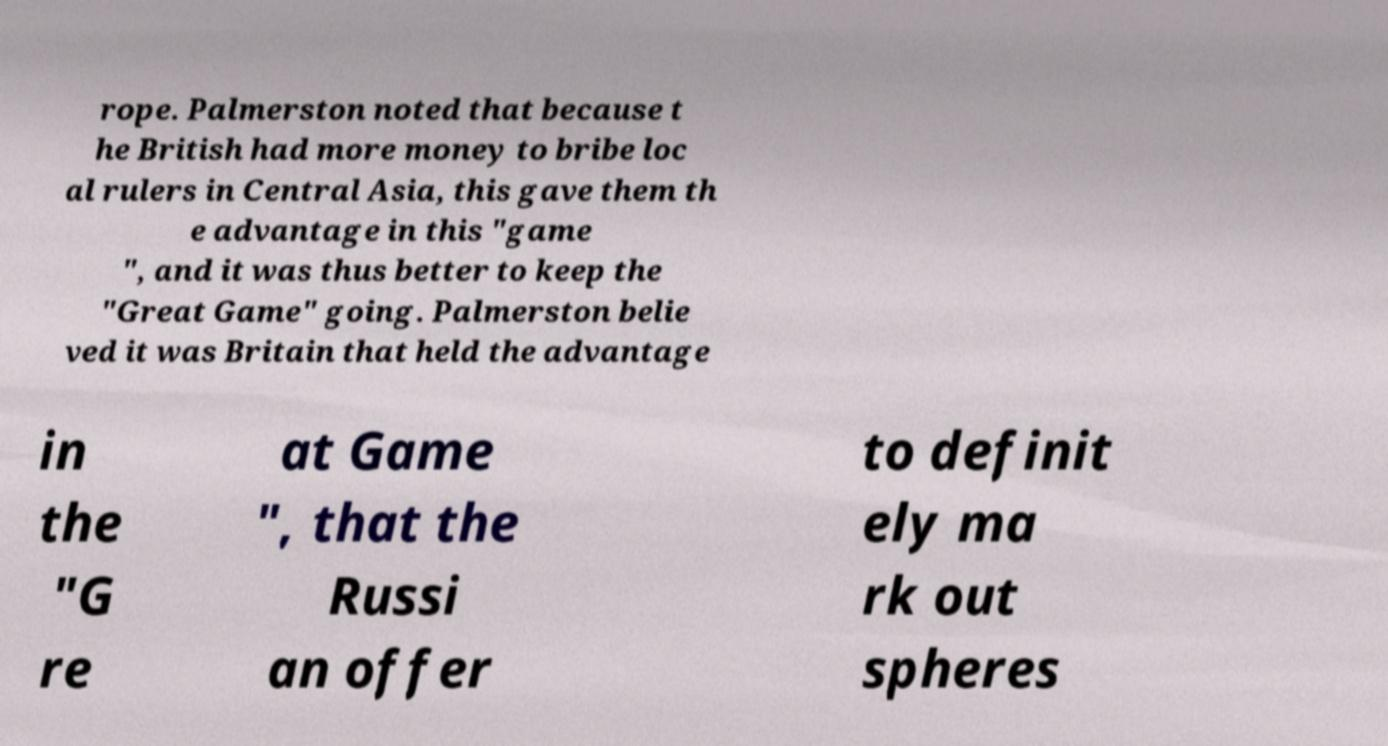What messages or text are displayed in this image? I need them in a readable, typed format. rope. Palmerston noted that because t he British had more money to bribe loc al rulers in Central Asia, this gave them th e advantage in this "game ", and it was thus better to keep the "Great Game" going. Palmerston belie ved it was Britain that held the advantage in the "G re at Game ", that the Russi an offer to definit ely ma rk out spheres 